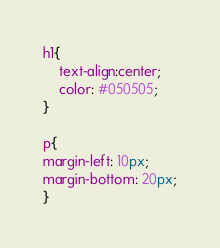Convert code to text. <code><loc_0><loc_0><loc_500><loc_500><_CSS_>h1{
    text-align:center;
    color: #050505;
}

p{
margin-left: 10px;
margin-bottom: 20px;
}</code> 